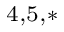<formula> <loc_0><loc_0><loc_500><loc_500>^ { 4 , 5 , * }</formula> 